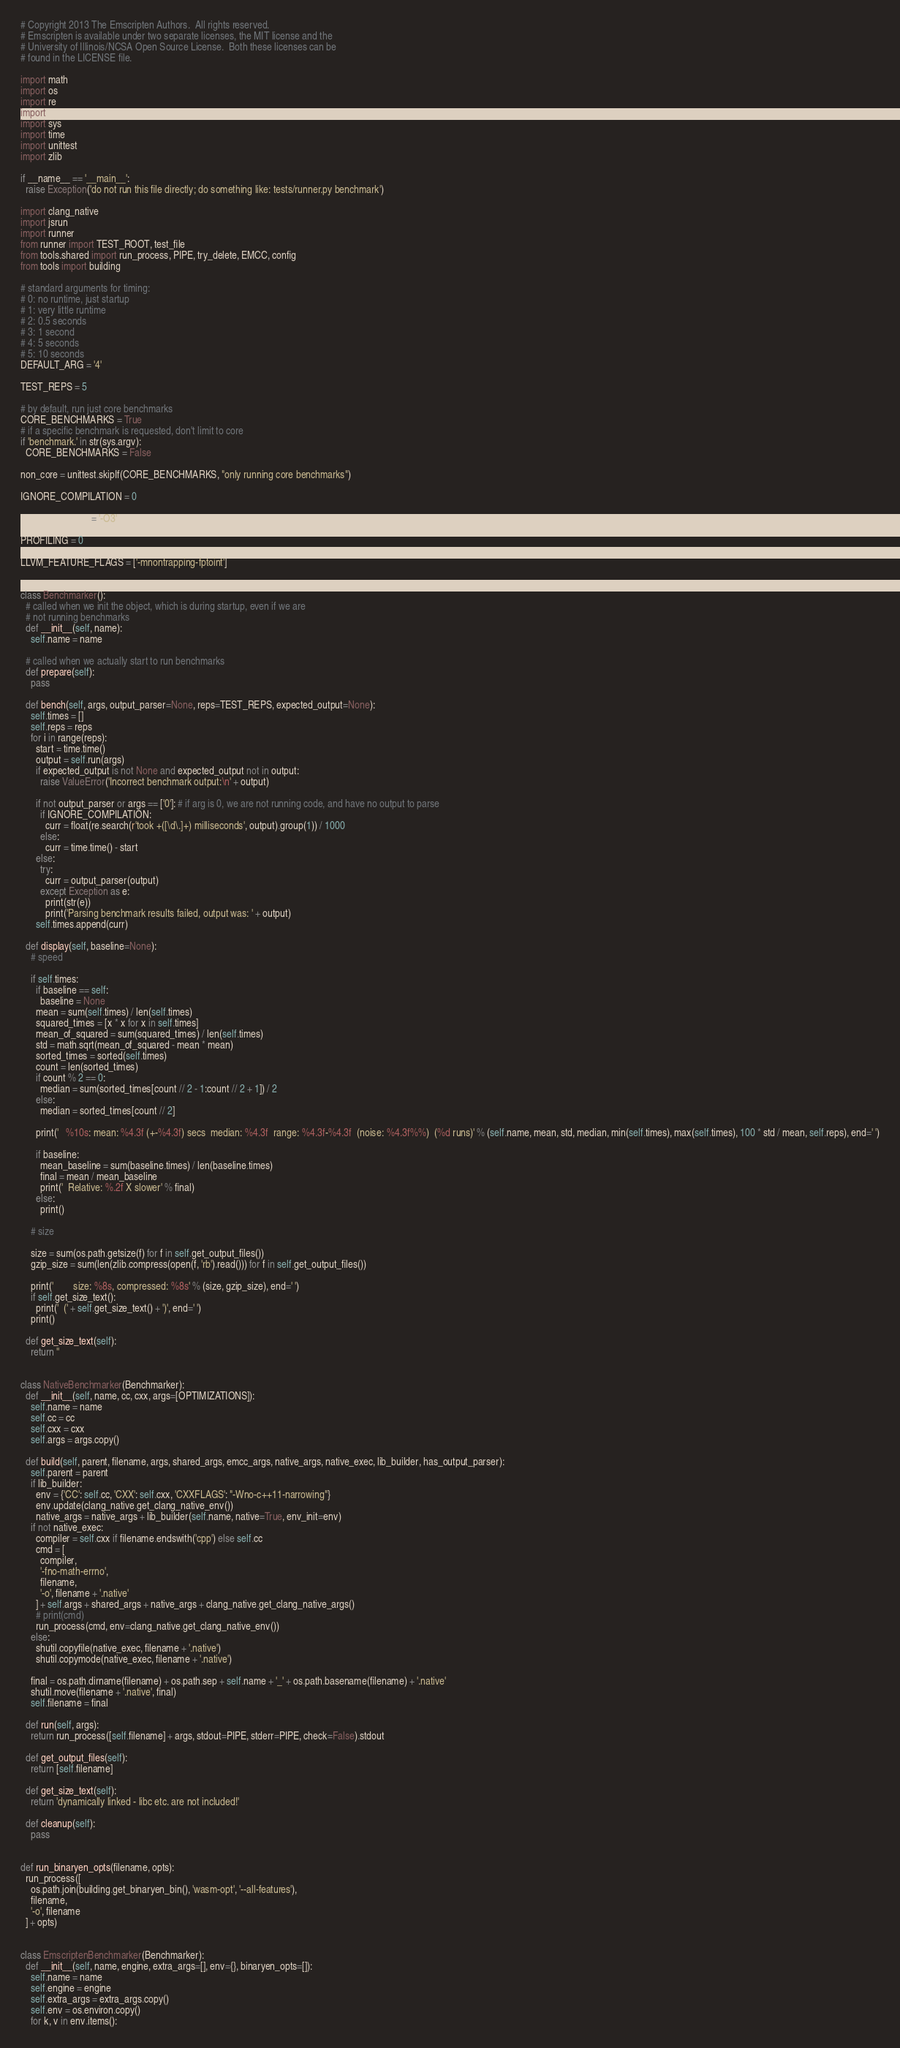Convert code to text. <code><loc_0><loc_0><loc_500><loc_500><_Python_># Copyright 2013 The Emscripten Authors.  All rights reserved.
# Emscripten is available under two separate licenses, the MIT license and the
# University of Illinois/NCSA Open Source License.  Both these licenses can be
# found in the LICENSE file.

import math
import os
import re
import shutil
import sys
import time
import unittest
import zlib

if __name__ == '__main__':
  raise Exception('do not run this file directly; do something like: tests/runner.py benchmark')

import clang_native
import jsrun
import runner
from runner import TEST_ROOT, test_file
from tools.shared import run_process, PIPE, try_delete, EMCC, config
from tools import building

# standard arguments for timing:
# 0: no runtime, just startup
# 1: very little runtime
# 2: 0.5 seconds
# 3: 1 second
# 4: 5 seconds
# 5: 10 seconds
DEFAULT_ARG = '4'

TEST_REPS = 5

# by default, run just core benchmarks
CORE_BENCHMARKS = True
# if a specific benchmark is requested, don't limit to core
if 'benchmark.' in str(sys.argv):
  CORE_BENCHMARKS = False

non_core = unittest.skipIf(CORE_BENCHMARKS, "only running core benchmarks")

IGNORE_COMPILATION = 0

OPTIMIZATIONS = '-O3'

PROFILING = 0

LLVM_FEATURE_FLAGS = ['-mnontrapping-fptoint']


class Benchmarker():
  # called when we init the object, which is during startup, even if we are
  # not running benchmarks
  def __init__(self, name):
    self.name = name

  # called when we actually start to run benchmarks
  def prepare(self):
    pass

  def bench(self, args, output_parser=None, reps=TEST_REPS, expected_output=None):
    self.times = []
    self.reps = reps
    for i in range(reps):
      start = time.time()
      output = self.run(args)
      if expected_output is not None and expected_output not in output:
        raise ValueError('Incorrect benchmark output:\n' + output)

      if not output_parser or args == ['0']: # if arg is 0, we are not running code, and have no output to parse
        if IGNORE_COMPILATION:
          curr = float(re.search(r'took +([\d\.]+) milliseconds', output).group(1)) / 1000
        else:
          curr = time.time() - start
      else:
        try:
          curr = output_parser(output)
        except Exception as e:
          print(str(e))
          print('Parsing benchmark results failed, output was: ' + output)
      self.times.append(curr)

  def display(self, baseline=None):
    # speed

    if self.times:
      if baseline == self:
        baseline = None
      mean = sum(self.times) / len(self.times)
      squared_times = [x * x for x in self.times]
      mean_of_squared = sum(squared_times) / len(self.times)
      std = math.sqrt(mean_of_squared - mean * mean)
      sorted_times = sorted(self.times)
      count = len(sorted_times)
      if count % 2 == 0:
        median = sum(sorted_times[count // 2 - 1:count // 2 + 1]) / 2
      else:
        median = sorted_times[count // 2]

      print('   %10s: mean: %4.3f (+-%4.3f) secs  median: %4.3f  range: %4.3f-%4.3f  (noise: %4.3f%%)  (%d runs)' % (self.name, mean, std, median, min(self.times), max(self.times), 100 * std / mean, self.reps), end=' ')

      if baseline:
        mean_baseline = sum(baseline.times) / len(baseline.times)
        final = mean / mean_baseline
        print('  Relative: %.2f X slower' % final)
      else:
        print()

    # size

    size = sum(os.path.getsize(f) for f in self.get_output_files())
    gzip_size = sum(len(zlib.compress(open(f, 'rb').read())) for f in self.get_output_files())

    print('        size: %8s, compressed: %8s' % (size, gzip_size), end=' ')
    if self.get_size_text():
      print('  (' + self.get_size_text() + ')', end=' ')
    print()

  def get_size_text(self):
    return ''


class NativeBenchmarker(Benchmarker):
  def __init__(self, name, cc, cxx, args=[OPTIMIZATIONS]):
    self.name = name
    self.cc = cc
    self.cxx = cxx
    self.args = args.copy()

  def build(self, parent, filename, args, shared_args, emcc_args, native_args, native_exec, lib_builder, has_output_parser):
    self.parent = parent
    if lib_builder:
      env = {'CC': self.cc, 'CXX': self.cxx, 'CXXFLAGS': "-Wno-c++11-narrowing"}
      env.update(clang_native.get_clang_native_env())
      native_args = native_args + lib_builder(self.name, native=True, env_init=env)
    if not native_exec:
      compiler = self.cxx if filename.endswith('cpp') else self.cc
      cmd = [
        compiler,
        '-fno-math-errno',
        filename,
        '-o', filename + '.native'
      ] + self.args + shared_args + native_args + clang_native.get_clang_native_args()
      # print(cmd)
      run_process(cmd, env=clang_native.get_clang_native_env())
    else:
      shutil.copyfile(native_exec, filename + '.native')
      shutil.copymode(native_exec, filename + '.native')

    final = os.path.dirname(filename) + os.path.sep + self.name + '_' + os.path.basename(filename) + '.native'
    shutil.move(filename + '.native', final)
    self.filename = final

  def run(self, args):
    return run_process([self.filename] + args, stdout=PIPE, stderr=PIPE, check=False).stdout

  def get_output_files(self):
    return [self.filename]

  def get_size_text(self):
    return 'dynamically linked - libc etc. are not included!'

  def cleanup(self):
    pass


def run_binaryen_opts(filename, opts):
  run_process([
    os.path.join(building.get_binaryen_bin(), 'wasm-opt', '--all-features'),
    filename,
    '-o', filename
  ] + opts)


class EmscriptenBenchmarker(Benchmarker):
  def __init__(self, name, engine, extra_args=[], env={}, binaryen_opts=[]):
    self.name = name
    self.engine = engine
    self.extra_args = extra_args.copy()
    self.env = os.environ.copy()
    for k, v in env.items():</code> 